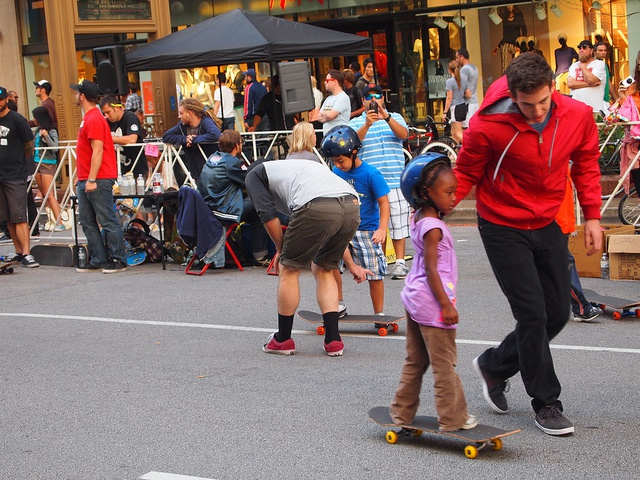Describe the objects in this image and their specific colors. I can see people in gray, black, red, maroon, and brown tones, people in gray, black, maroon, and brown tones, people in gray, black, and lightgray tones, people in gray, brown, maroon, violet, and black tones, and people in gray, black, and red tones in this image. 